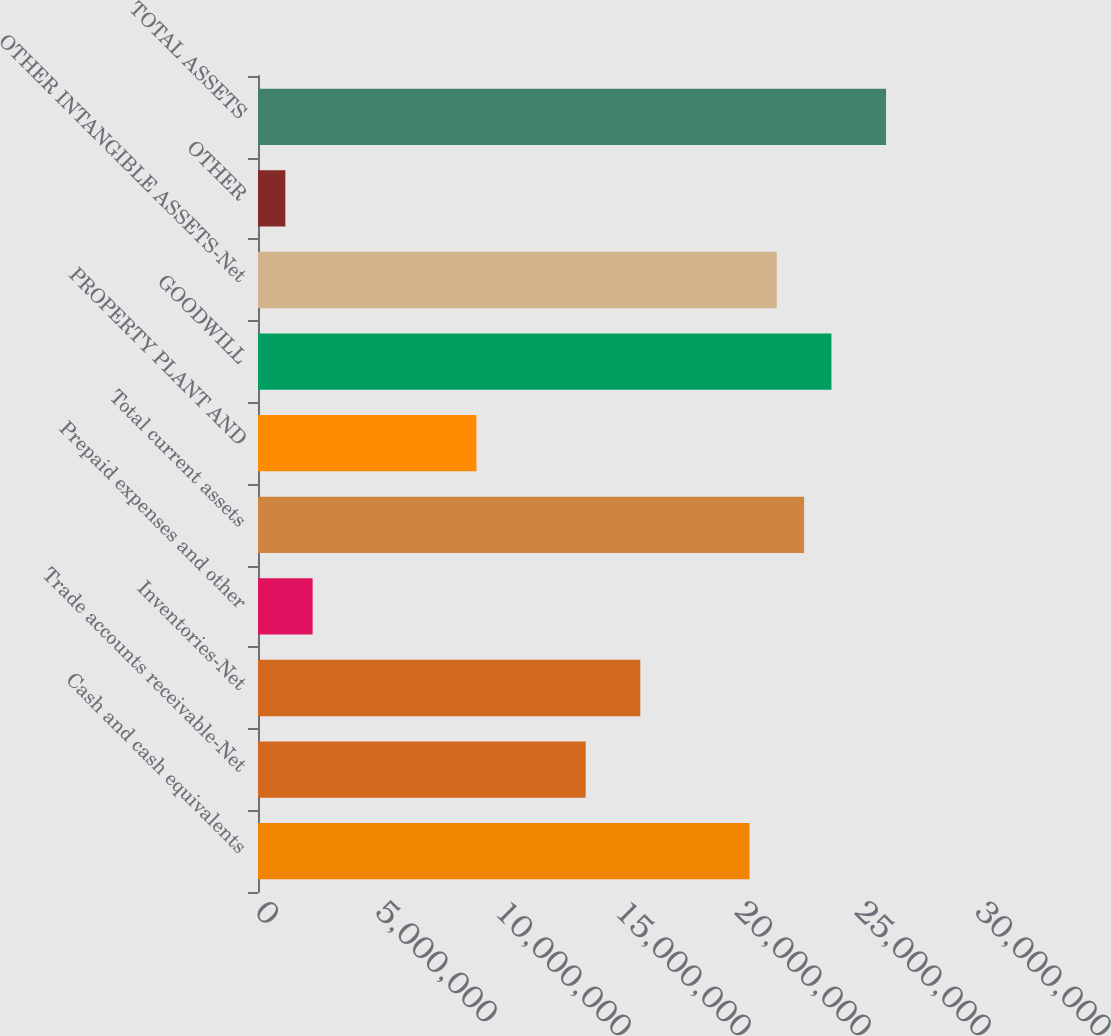Convert chart. <chart><loc_0><loc_0><loc_500><loc_500><bar_chart><fcel>Cash and cash equivalents<fcel>Trade accounts receivable-Net<fcel>Inventories-Net<fcel>Prepaid expenses and other<fcel>Total current assets<fcel>PROPERTY PLANT AND<fcel>GOODWILL<fcel>OTHER INTANGIBLE ASSETS-Net<fcel>OTHER<fcel>TOTAL ASSETS<nl><fcel>2.04795e+07<fcel>1.36532e+07<fcel>1.59287e+07<fcel>2.276e+06<fcel>2.2755e+07<fcel>9.10233e+06<fcel>2.38927e+07<fcel>2.16173e+07<fcel>1.13828e+06<fcel>2.61681e+07<nl></chart> 